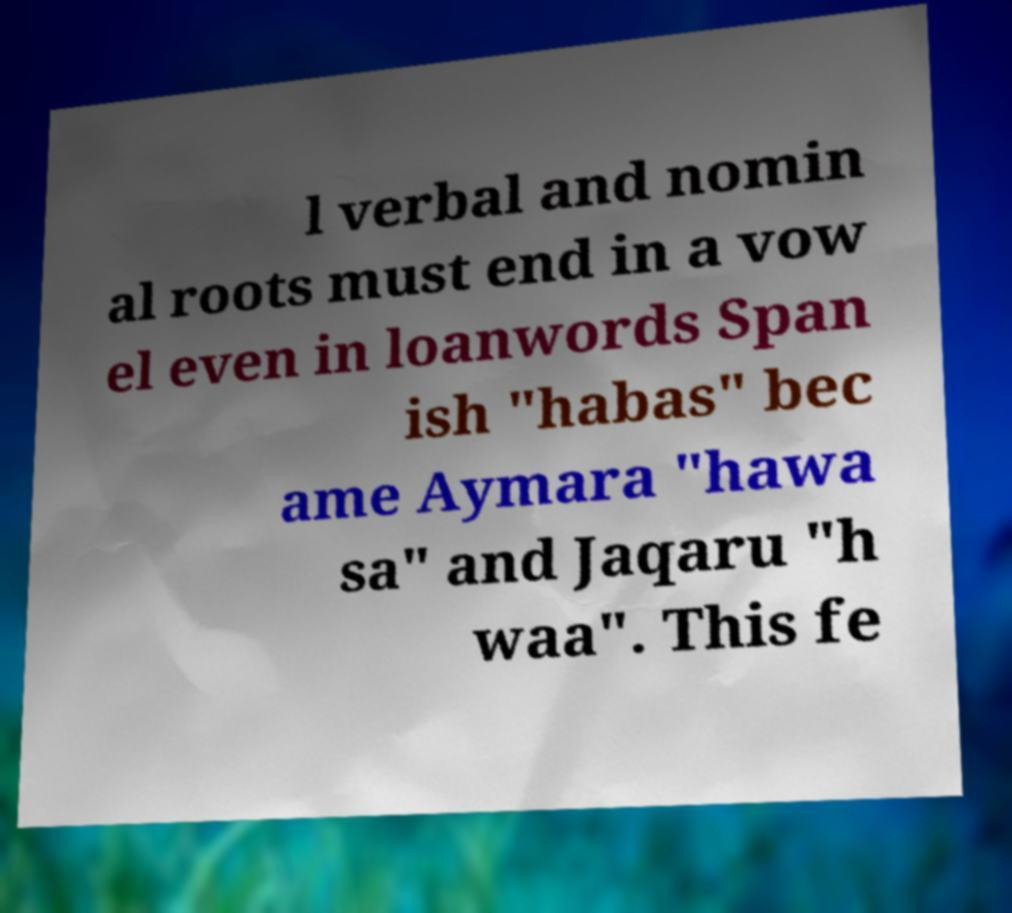Please identify and transcribe the text found in this image. l verbal and nomin al roots must end in a vow el even in loanwords Span ish "habas" bec ame Aymara "hawa sa" and Jaqaru "h waa". This fe 